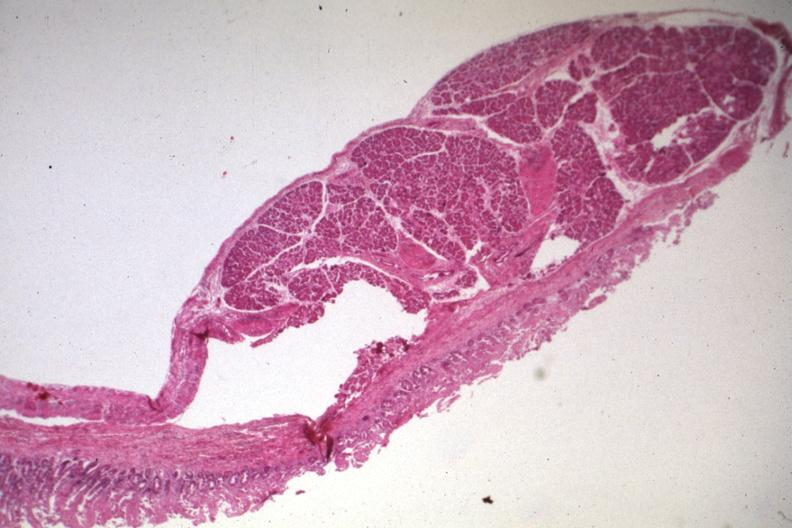what is present?
Answer the question using a single word or phrase. Jejunum 